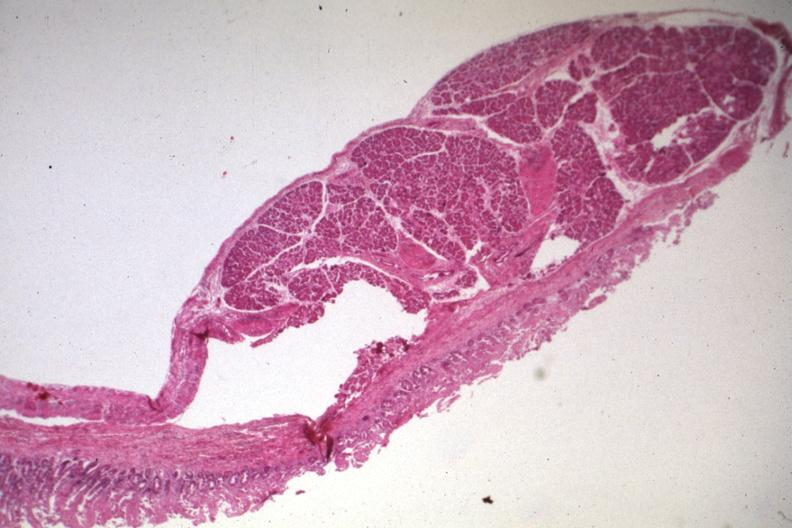what is present?
Answer the question using a single word or phrase. Jejunum 